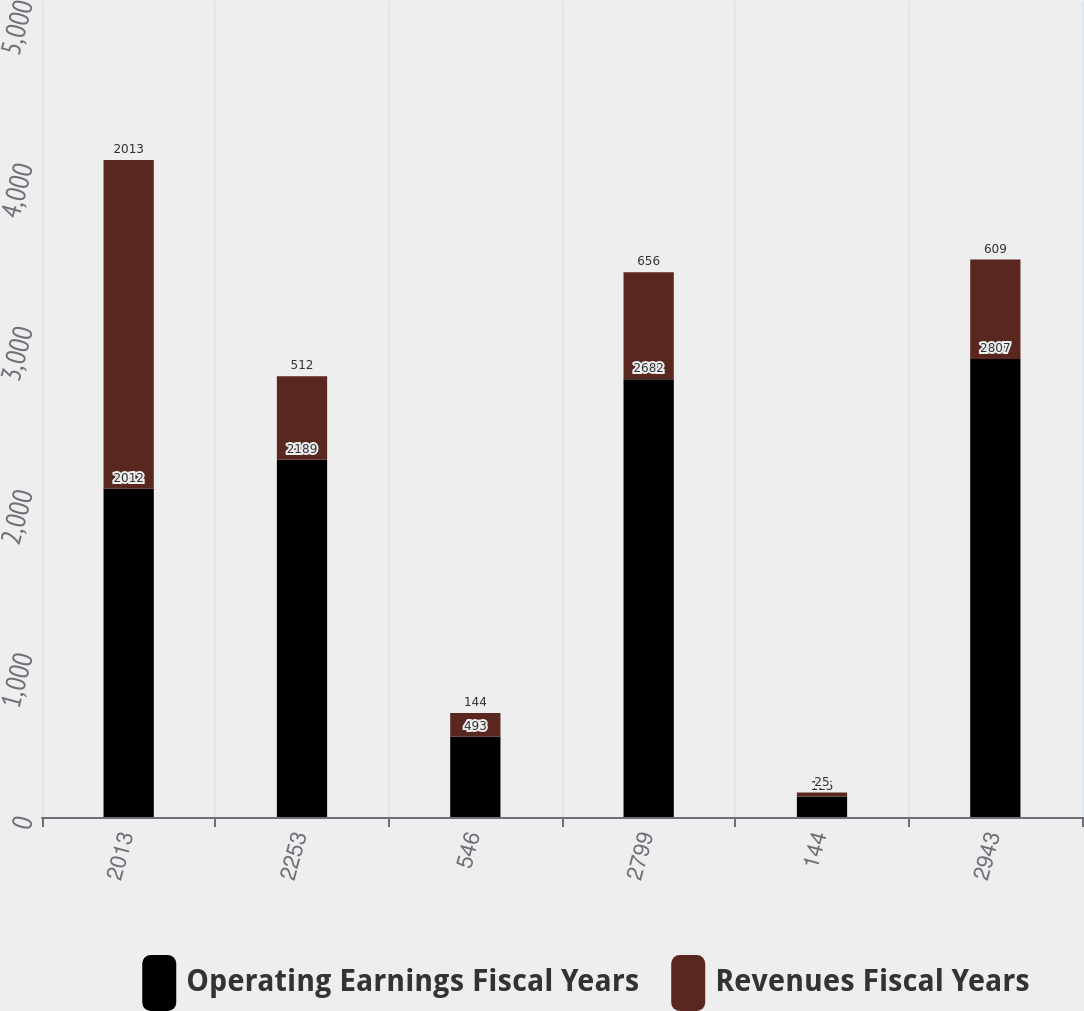Convert chart. <chart><loc_0><loc_0><loc_500><loc_500><stacked_bar_chart><ecel><fcel>2013<fcel>2253<fcel>546<fcel>2799<fcel>144<fcel>2943<nl><fcel>Operating Earnings Fiscal Years<fcel>2012<fcel>2189<fcel>493<fcel>2682<fcel>125<fcel>2807<nl><fcel>Revenues Fiscal Years<fcel>2013<fcel>512<fcel>144<fcel>656<fcel>25<fcel>609<nl></chart> 